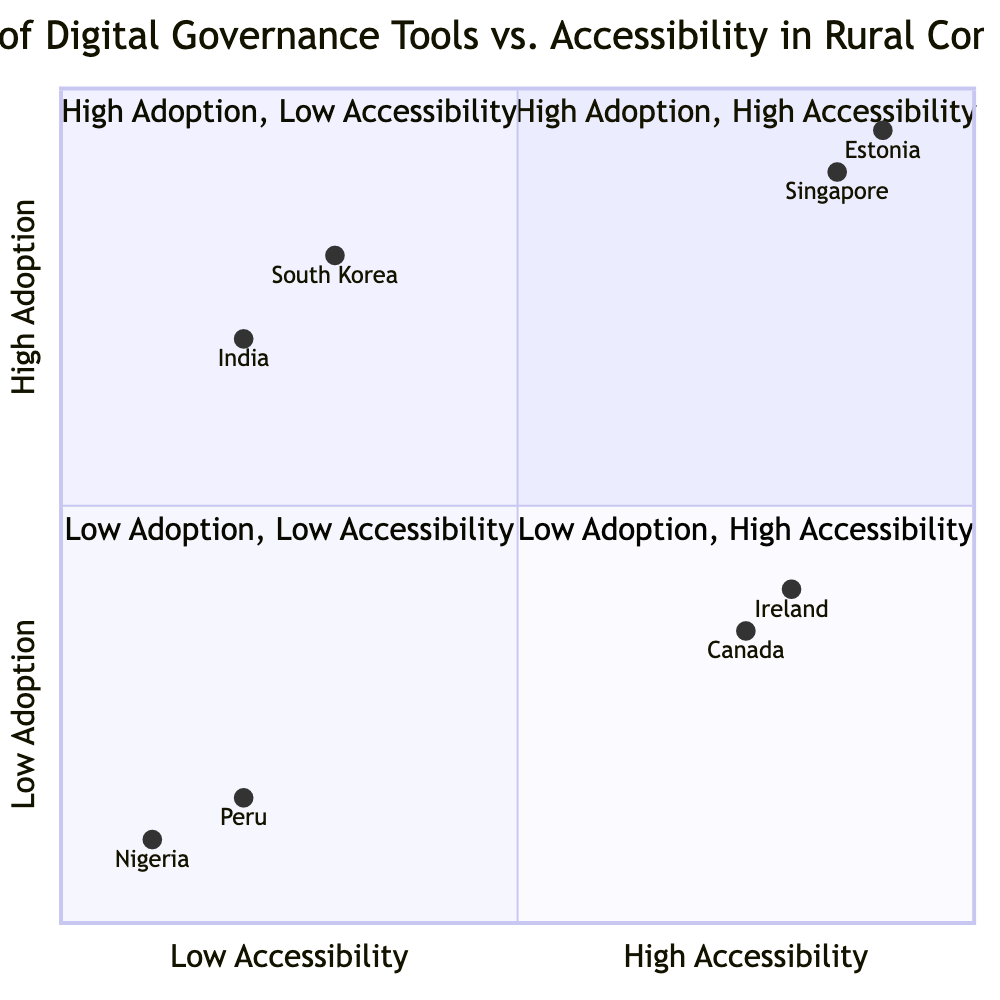What countries are in the "High Adoption, High Accessibility" quadrant? The "High Adoption, High Accessibility" quadrant contains Estonia and Singapore, which are listed as having comprehensive digital governance structures and high accessibility levels.
Answer: Estonia, Singapore Which country has the lowest adoption and accessibility score? The country with the lowest adoption and accessibility score is Nigeria, which is located at the coordinates [0.1, 0.1], indicating both low adoption and low accessibility of digital governance tools.
Answer: Nigeria How many countries are in the "Low Adoption, Low Accessibility" quadrant? There are two countries in the "Low Adoption, Low Accessibility" quadrant: Peru and Nigeria, which both have limited digital governance initiatives paired with low internet penetration.
Answer: 2 What is the adoption score for South Korea? The adoption score for South Korea is 0.8, as represented by its coordinate [0.3, 0.8] in the quadrant chart. This places it in the "High Adoption, Low Accessibility" quadrant.
Answer: 0.8 Which country has high accessibility but low adoption? Ireland has high accessibility but low adoption, indicated by its placement in the "Low Adoption, High Accessibility" quadrant, with a score of [0.8, 0.4].
Answer: Ireland What is the accessibility score for Canada? The accessibility score for Canada is 0.35, as indicated by its coordinates [0.75, 0.35] in the quadrant chart. This shows it has low adoption and moderate accessibility in rural areas.
Answer: 0.35 Which quadrant contains countries that have high adoption yet low accessibility? The "High Adoption, Low Accessibility" quadrant contains South Korea and India, which have extensive digital governance tools but face limitations in terms of rural internet coverage.
Answer: High Adoption, Low Accessibility How many countries are categorized under low adoption? Four countries are categorized under low adoption: Peru, Nigeria, Ireland, and Canada, as their scores indicate lower levels of adoption compared to others in the chart.
Answer: 4 What distinguishes Estonia from Nigeria in the quadrant chart? Estonia is in the "High Adoption, High Accessibility" quadrant, showing robust digital governance and internet access, while Nigeria is in the "Low Adoption, Low Accessibility" quadrant, reflecting poor digital governance and internet penetration.
Answer: High adoption, high accessibility vs. Low adoption, low accessibility 